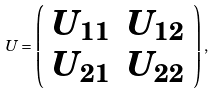<formula> <loc_0><loc_0><loc_500><loc_500>U = \left ( \begin{array} { c c } U _ { 1 1 } & U _ { 1 2 } \\ U _ { 2 1 } & U _ { 2 2 } \end{array} \right ) ,</formula> 